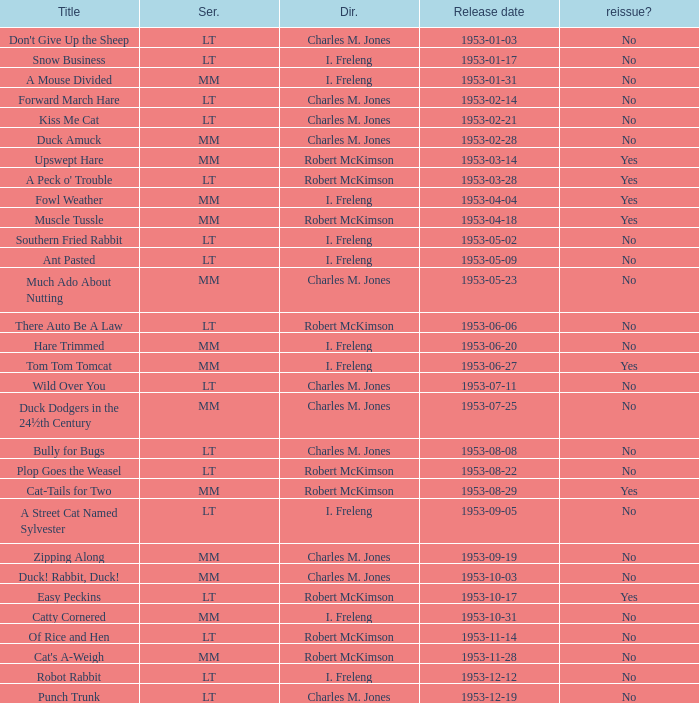Was there a reissue of the film released on 1953-10-03? No. 